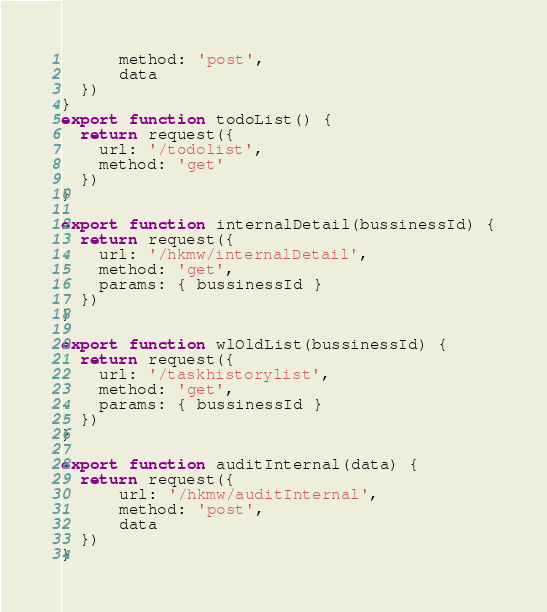<code> <loc_0><loc_0><loc_500><loc_500><_JavaScript_>      method: 'post',
      data
  })
}
export function todoList() {
  return request({
    url: '/todolist',
    method: 'get'
  })
}

export function internalDetail(bussinessId) {
  return request({
    url: '/hkmw/internalDetail',
    method: 'get',
    params: { bussinessId }
  })
}

export function wlOldList(bussinessId) {
  return request({
    url: '/taskhistorylist',
    method: 'get',
    params: { bussinessId }
  })
}

export function auditInternal(data) {
  return request({
      url: '/hkmw/auditInternal',
      method: 'post',
      data
  })
}</code> 